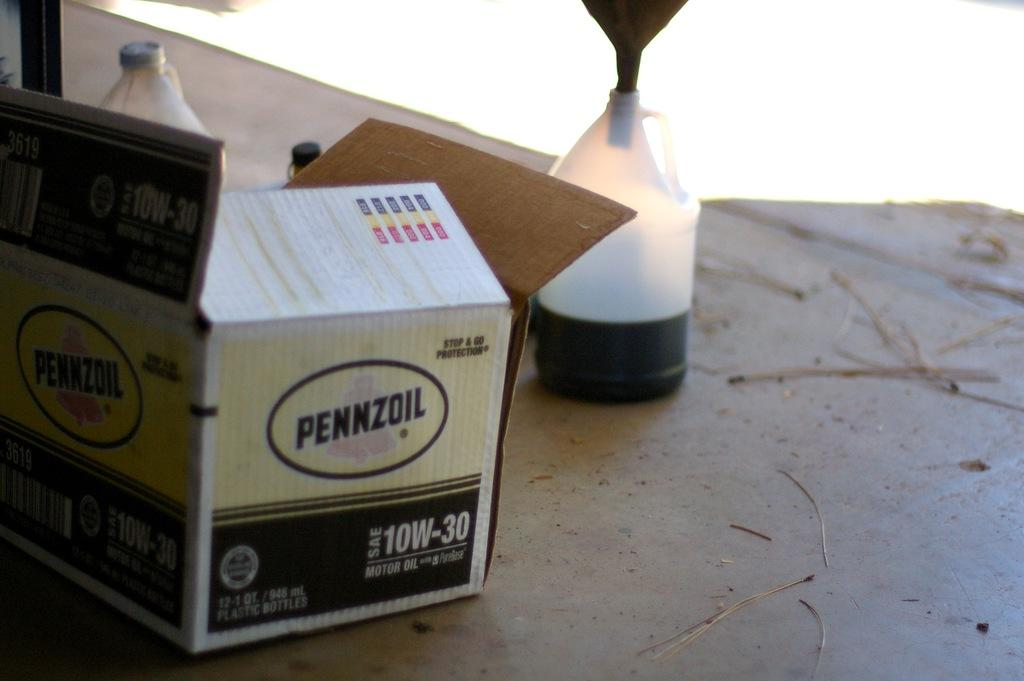<image>
Give a short and clear explanation of the subsequent image. A box containing a dozen containers of Pennzoil oil. 